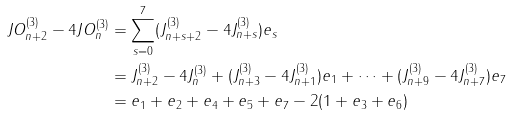<formula> <loc_0><loc_0><loc_500><loc_500>J O _ { n + 2 } ^ { ( 3 ) } - 4 J O _ { n } ^ { ( 3 ) } & = \sum _ { s = 0 } ^ { 7 } ( J _ { n + s + 2 } ^ { ( 3 ) } - 4 J _ { n + s } ^ { ( 3 ) } ) e _ { s } \\ & = J _ { n + 2 } ^ { ( 3 ) } - 4 J _ { n } ^ { ( 3 ) } + ( J _ { n + 3 } ^ { ( 3 ) } - 4 J _ { n + 1 } ^ { ( 3 ) } ) e _ { 1 } + \cdots + ( J _ { n + 9 } ^ { ( 3 ) } - 4 J _ { n + 7 } ^ { ( 3 ) } ) e _ { 7 } \\ & = e _ { 1 } + e _ { 2 } + e _ { 4 } + e _ { 5 } + e _ { 7 } - 2 ( 1 + e _ { 3 } + e _ { 6 } )</formula> 